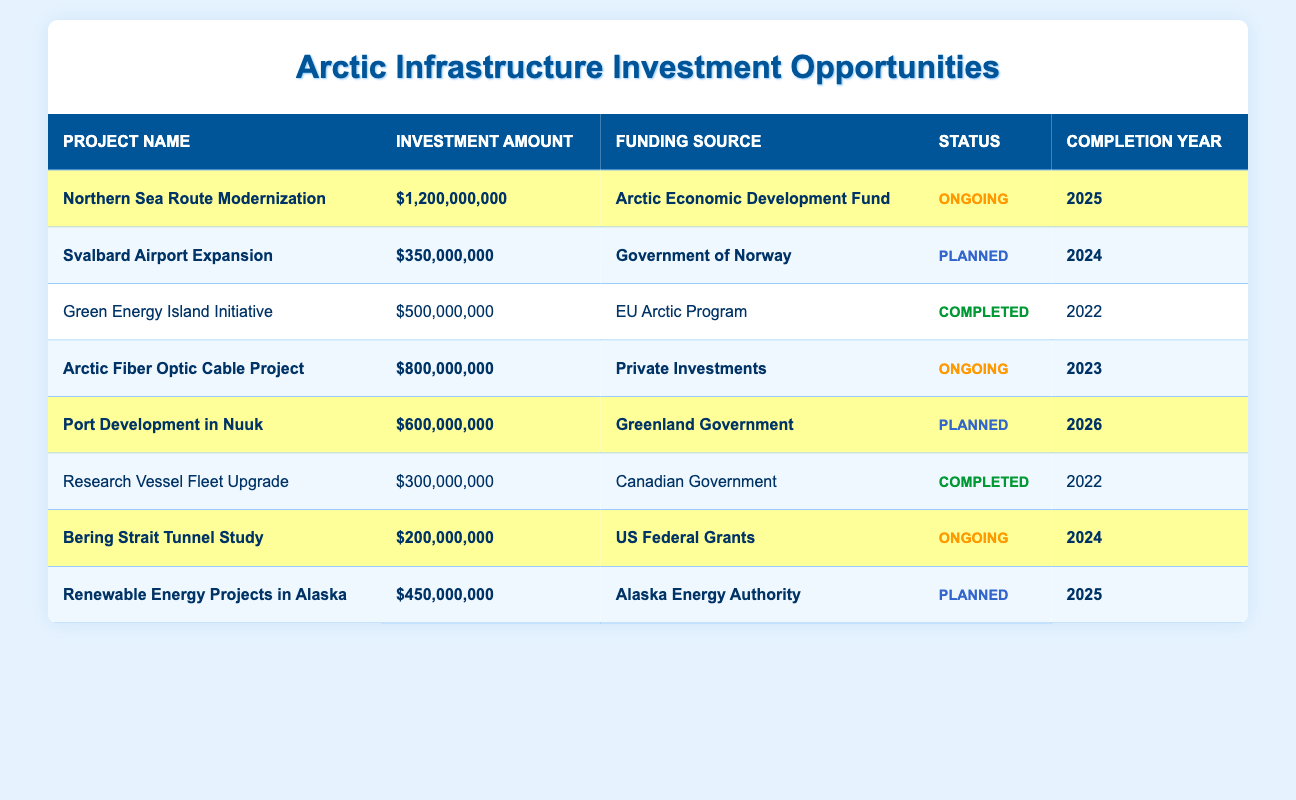What is the total investment amount for the highlighted projects? The highlighted projects include: Northern Sea Route Modernization ($1,200,000,000), Svalbard Airport Expansion ($350,000,000), Arctic Fiber Optic Cable Project ($800,000,000), Port Development in Nuuk ($600,000,000), Bering Strait Tunnel Study ($200,000,000), and Renewable Energy Projects in Alaska ($450,000,000). Adding these amounts gives $1,200,000,000 + $350,000,000 + $800,000,000 + $600,000,000 + $200,000,000 + $450,000,000 = $3,650,000,000.
Answer: $3,650,000,000 Which project has the highest investment amount? By comparing the investment amounts in the table, the Northern Sea Route Modernization project has the highest investment of $1,200,000,000.
Answer: Northern Sea Route Modernization How many projects are planned for completion in 2024? There are two projects planned for completion in 2024: Svalbard Airport Expansion and Bering Strait Tunnel Study.
Answer: 2 Is the Arctic Fiber Optic Cable Project ongoing? According to the table, the status of the Arctic Fiber Optic Cable Project is marked as ongoing.
Answer: Yes What is the average investment amount for the ongoing projects? The ongoing projects are Northern Sea Route Modernization ($1,200,000,000), Arctic Fiber Optic Cable Project ($800,000,000), and Bering Strait Tunnel Study ($200,000,000). The total investment for these projects is $1,200,000,000 + $800,000,000 + $200,000,000 = $2,200,000,000. There are 3 ongoing projects, so the average amount is $2,200,000,000 / 3 = $733,333,333.33.
Answer: $733,333,333.33 Are there any completed projects mentioned in the table? Yes, there are completed projects: Green Energy Island Initiative and Research Vessel Fleet Upgrade.
Answer: Yes What is the difference in investment amounts between the Northern Sea Route Modernization and the Svalbard Airport Expansion? The investment amount for the Northern Sea Route Modernization is $1,200,000,000 and for the Svalbard Airport Expansion is $350,000,000. The difference is $1,200,000,000 - $350,000,000 = $850,000,000.
Answer: $850,000,000 Which funding source is associated with the Port Development in Nuuk? The table lists the Greenland Government as the funding source for the Port Development in Nuuk.
Answer: Greenland Government How many projects have a completion year in or before 2025? The projects with completion years in or before 2025 are: Green Energy Island Initiative (2022), Research Vessel Fleet Upgrade (2022), Northern Sea Route Modernization (2025), Svalbard Airport Expansion (2024), and Bering Strait Tunnel Study (2024). This totals to 5 projects.
Answer: 5 